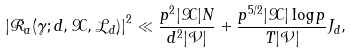Convert formula to latex. <formula><loc_0><loc_0><loc_500><loc_500>\left | \mathcal { R } _ { a } ( \gamma ; d , \mathcal { X } , \mathcal { L } _ { d } ) \right | ^ { 2 } \ll \frac { p ^ { 2 } | \mathcal { X } | N } { d ^ { 2 } | \mathcal { V } | } + \frac { p ^ { 5 / 2 } | \mathcal { X } | \log p } { T | \mathcal { V } | } J _ { d } ,</formula> 